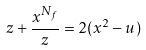<formula> <loc_0><loc_0><loc_500><loc_500>z + \frac { x ^ { N _ { f } } } { z } = 2 ( x ^ { 2 } - u )</formula> 